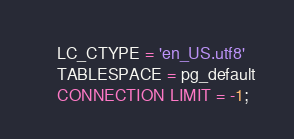Convert code to text. <code><loc_0><loc_0><loc_500><loc_500><_SQL_>    LC_CTYPE = 'en_US.utf8'
    TABLESPACE = pg_default
    CONNECTION LIMIT = -1;
</code> 